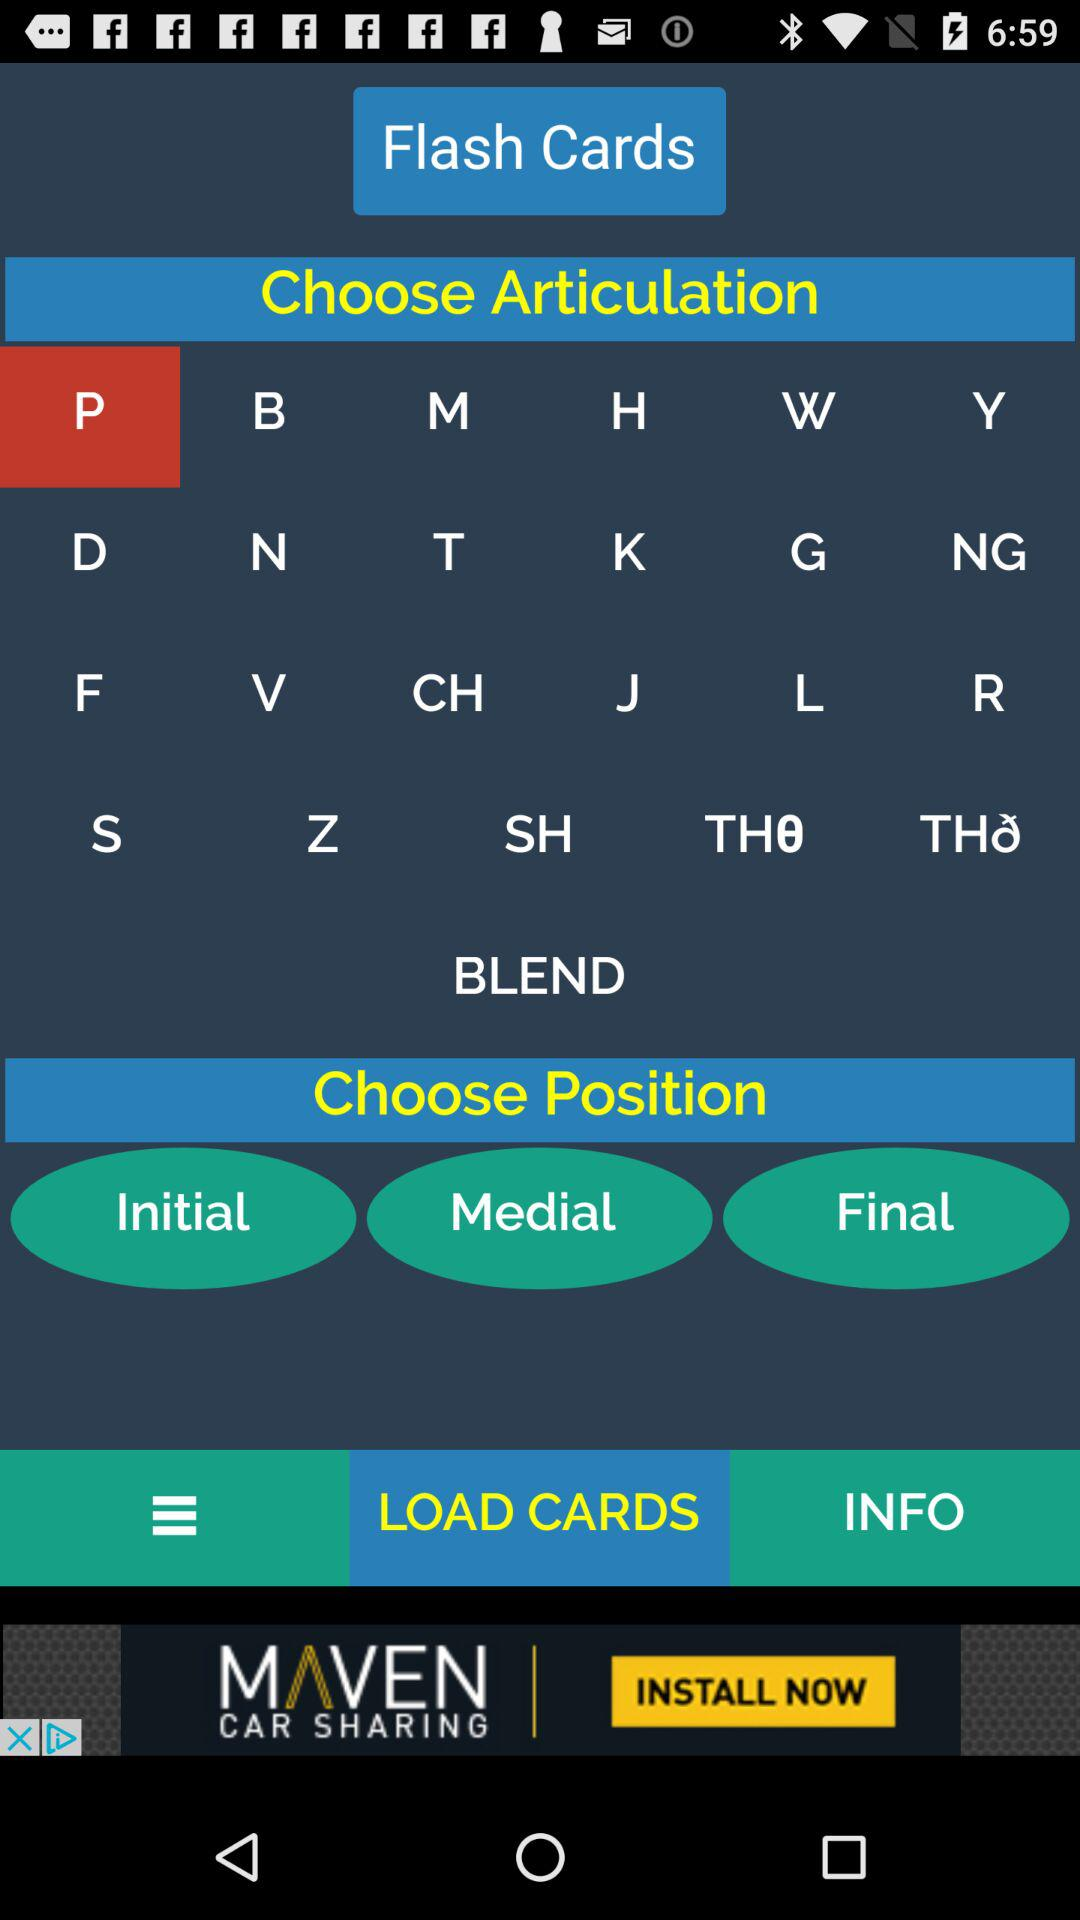What's the chosen articulation? The chosen articulation is "P". 